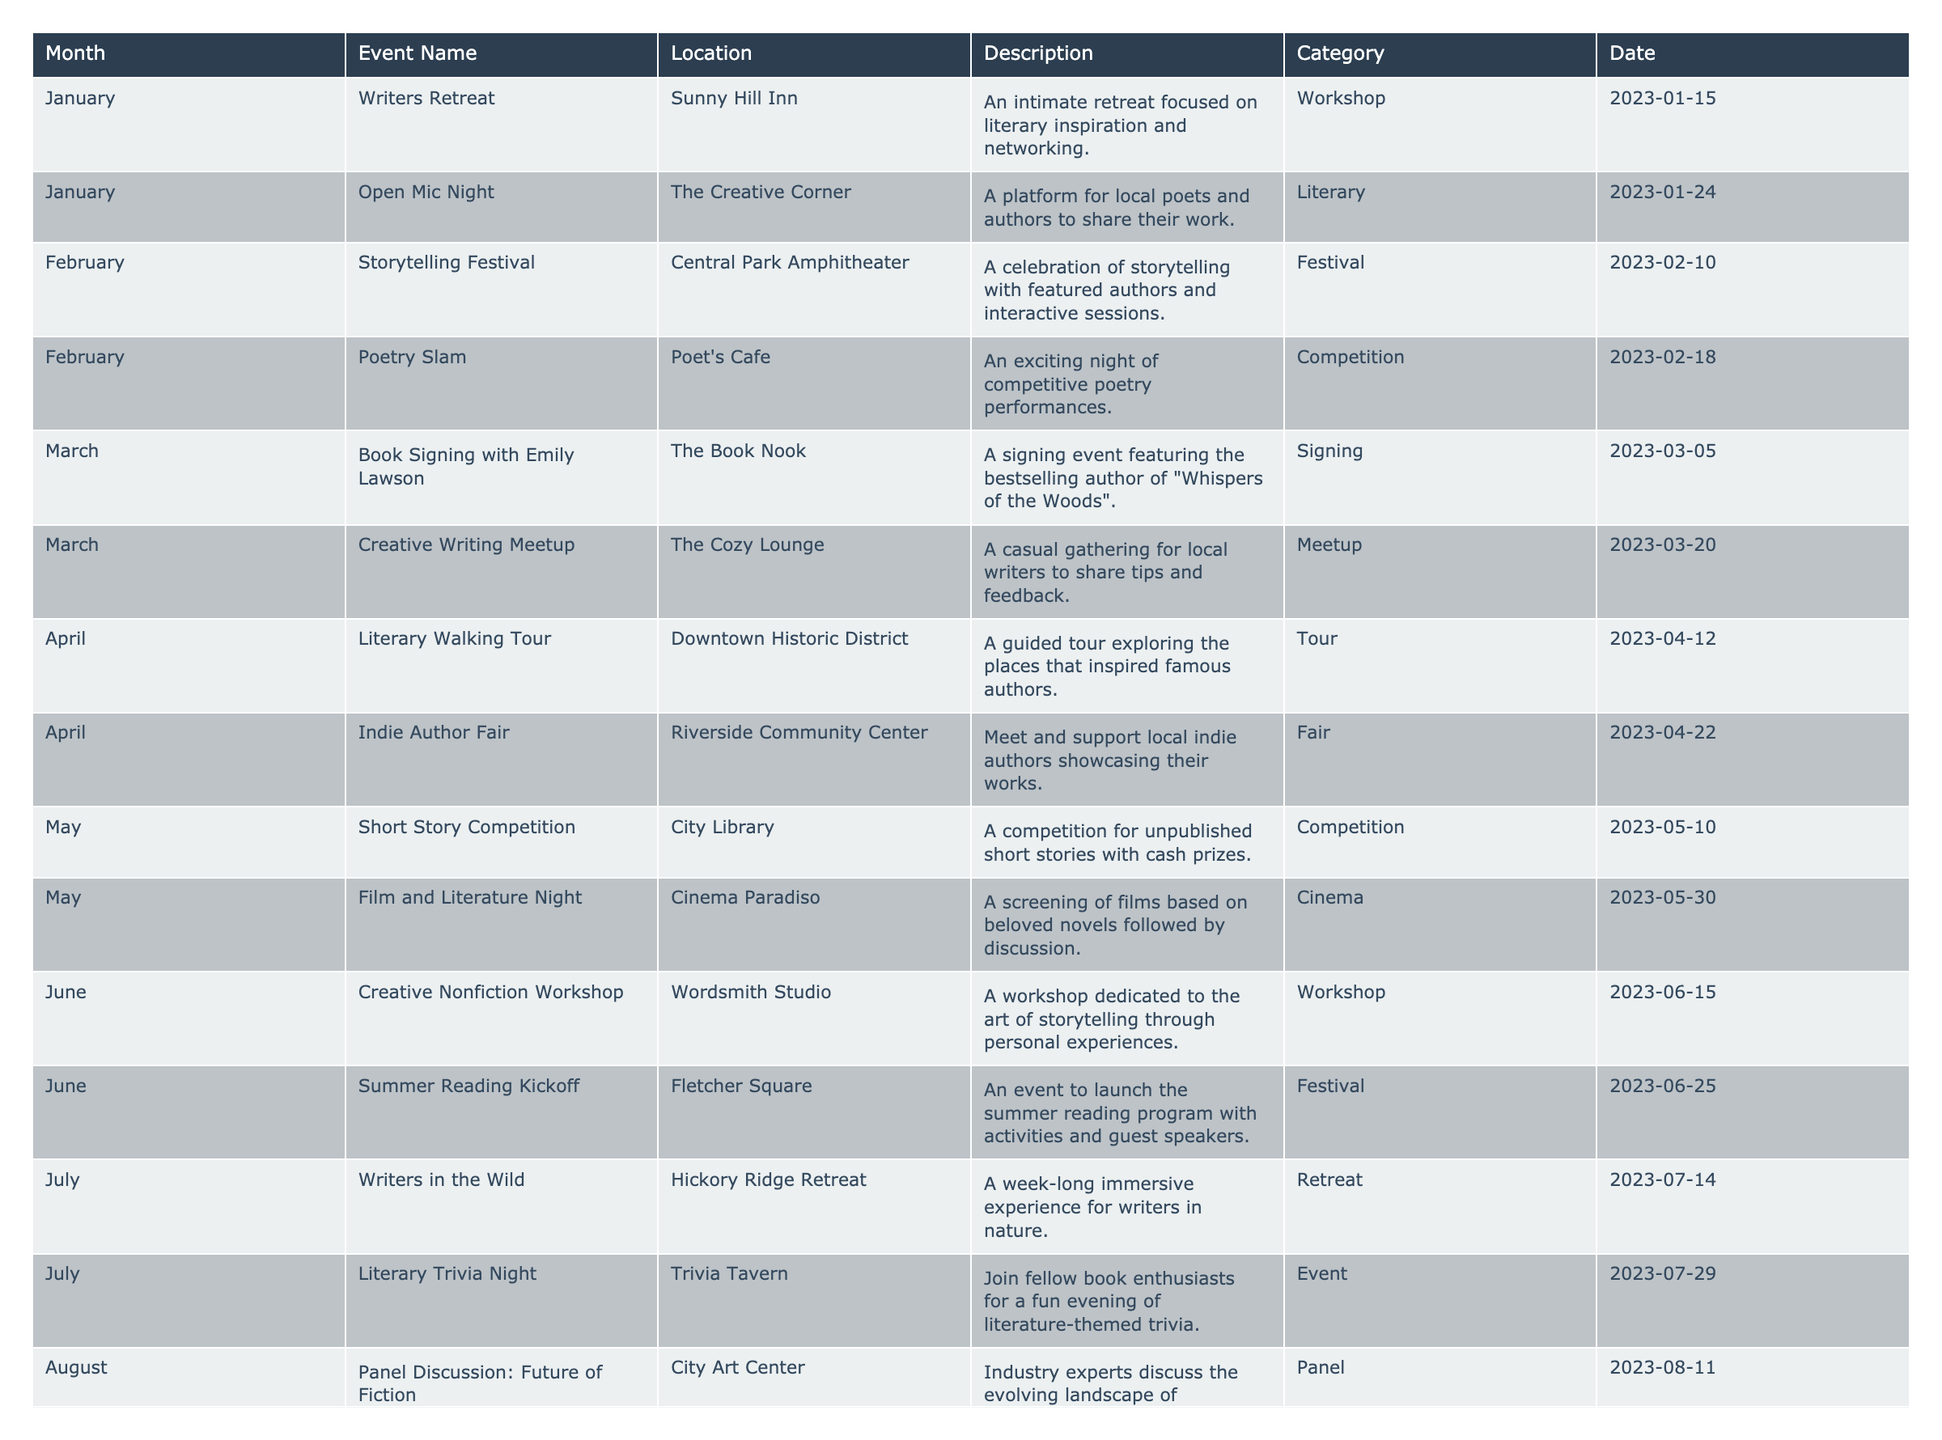What is the event happening in March? The table shows that in March, there are two events: "Book Signing with Emily Lawson" on March 5 and "Creative Writing Meetup" on March 20.
Answer: Book Signing with Emily Lawson and Creative Writing Meetup How many events are there in June? According to the table, there are two events in June: "Creative Nonfiction Workshop" and "Summer Reading Kickoff".
Answer: Two Which month has the "Storytelling Festival"? The "Storytelling Festival" is listed for February 10 in the table.
Answer: February What type of event is the "Writers Retreat"? The table indicates that the "Writers Retreat" is categorized as a Workshop.
Answer: Workshop What is the total number of events in the competition category? There are two events listed under the competition category: "Poetry Slam" and "Short Story Competition". Summing these gives us a total of 2.
Answer: Two Is there an event dedicated to non-fiction storytelling? Yes, the "Creative Nonfiction Workshop" is dedicated to this topic, which takes place in June.
Answer: Yes What can you infer about the frequency of literary workshops throughout the year? There are a total of four workshops throughout the months: January (Writers Retreat), June (Creative Nonfiction Workshop), September (NaNoWriMo Kickoff), and November (Fall Poetry Workshop). This indicates a steady interest in writing-focused gatherings.
Answer: Four workshops In which month do we see the highest number of events listed? By examining the table, we see that each month has a different count, but April has two events ("Literary Walking Tour" and "Indie Author Fair"), while most months have two or fewer.
Answer: April How many months feature a fair event? The table shows that there are two fairs: "Indie Author Fair" in April and "Holiday Book Fair" in December, resulting in a total of 2 months.
Answer: Two Can you name all events taking place in October? The events listed for October are "Spooky Story Night" on October 22 and "Author Talk: Historical Fiction" on October 30.
Answer: Spooky Story Night and Author Talk: Historical Fiction What kind of event is the "Literary Walking Tour"? The table categorizes the "Literary Walking Tour" as a Tour event.
Answer: Tour What is unique about the "NaNoWriMo Kickoff" event? It is specifically designed to help writers prepare for National Novel Writing Month with goal-setting workshops, taking place on September 5.
Answer: Helps writers prepare for NaNoWriMo Describe the time frame in which the "Film and Literature Night" occurs. The event is scheduled for May 30, which places it at the end of May, focusing on the connection between film and novels.
Answer: End of May 